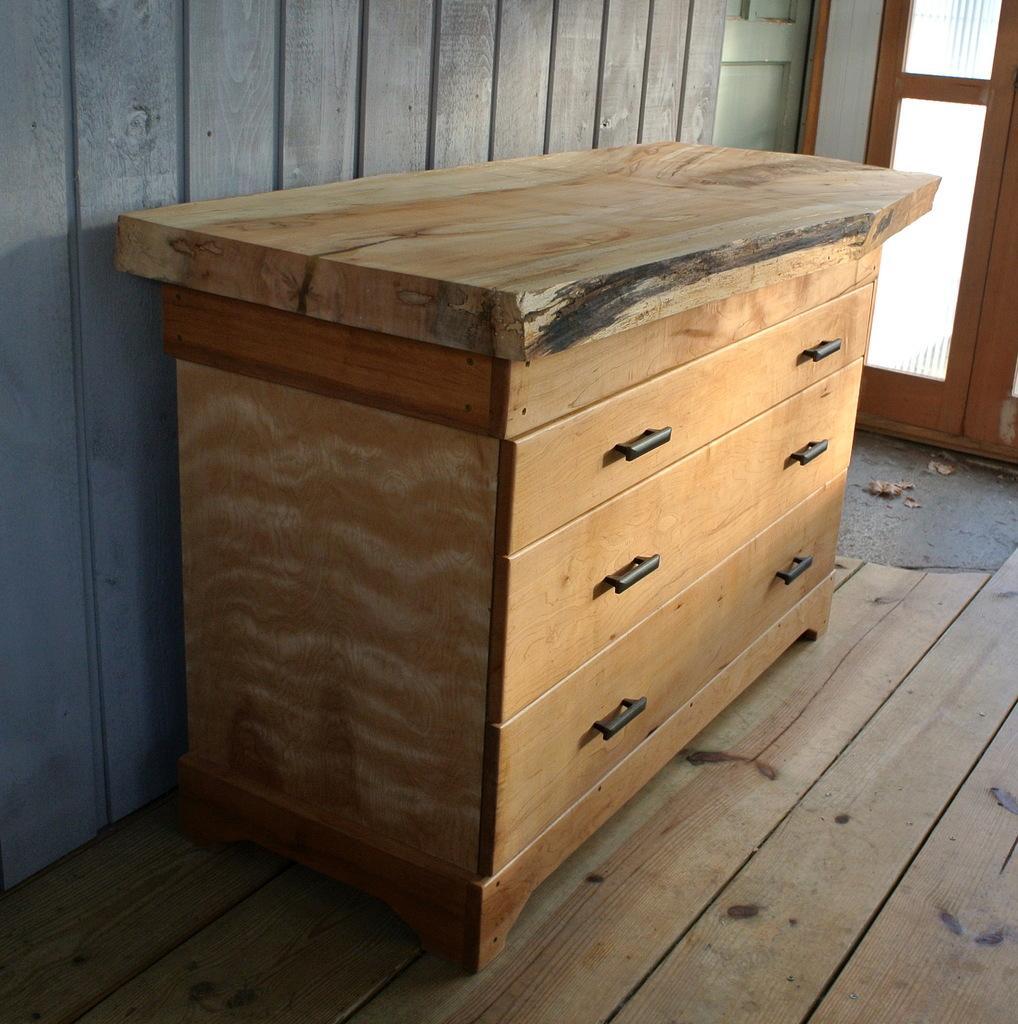Please provide a concise description of this image. This is the picture inside of the room. There is a table in the middle of the image. At the back there is a door. 